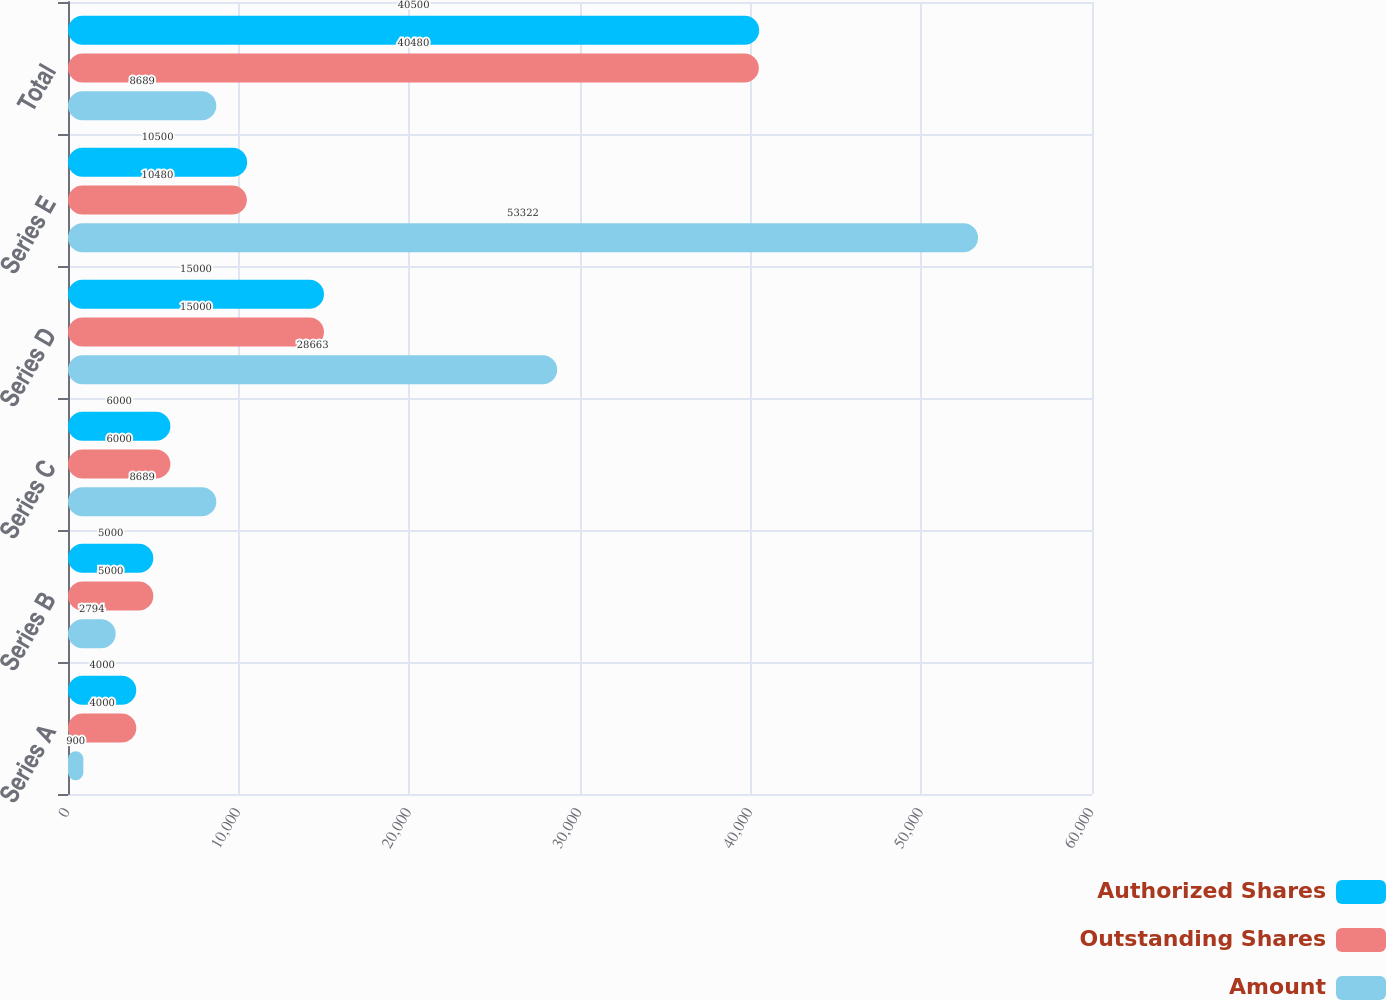<chart> <loc_0><loc_0><loc_500><loc_500><stacked_bar_chart><ecel><fcel>Series A<fcel>Series B<fcel>Series C<fcel>Series D<fcel>Series E<fcel>Total<nl><fcel>Authorized Shares<fcel>4000<fcel>5000<fcel>6000<fcel>15000<fcel>10500<fcel>40500<nl><fcel>Outstanding Shares<fcel>4000<fcel>5000<fcel>6000<fcel>15000<fcel>10480<fcel>40480<nl><fcel>Amount<fcel>900<fcel>2794<fcel>8689<fcel>28663<fcel>53322<fcel>8689<nl></chart> 